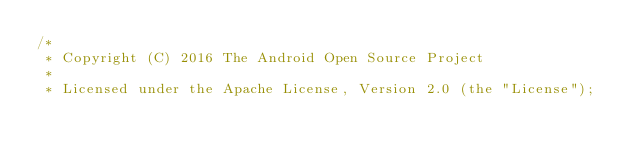<code> <loc_0><loc_0><loc_500><loc_500><_Java_>/*
 * Copyright (C) 2016 The Android Open Source Project
 *
 * Licensed under the Apache License, Version 2.0 (the "License");</code> 